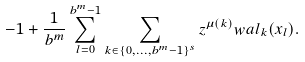Convert formula to latex. <formula><loc_0><loc_0><loc_500><loc_500>- 1 + \frac { 1 } { b ^ { m } } \sum _ { l = 0 } ^ { b ^ { m } - 1 } \sum _ { k \in \{ 0 , \dots , b ^ { m } - 1 \} ^ { s } } z ^ { \mu ( k ) } w a l _ { k } ( x _ { l } ) .</formula> 